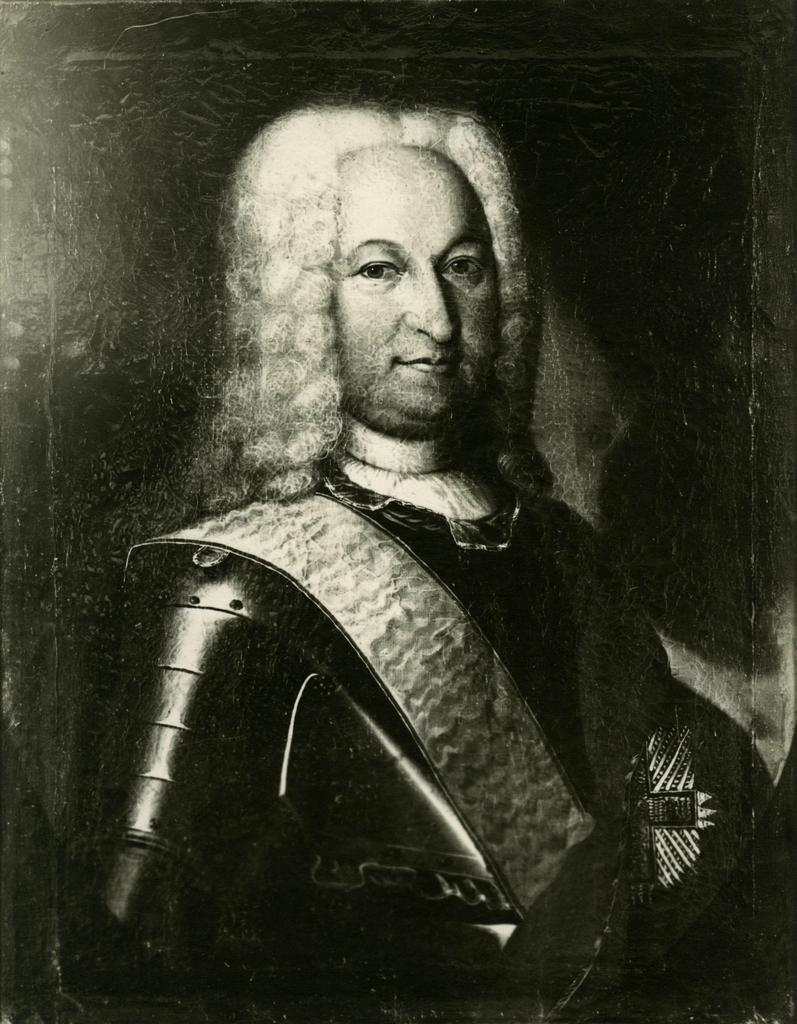What is the main subject of the image? There is a person standing in the image. What is the person wearing in the image? The person is wearing a jacket. What color scheme is used in the image? The image is in black and white color. What type of cable can be seen connecting the person's shoes in the image? There is no cable connecting the person's shoes in the image; the person is simply standing. 